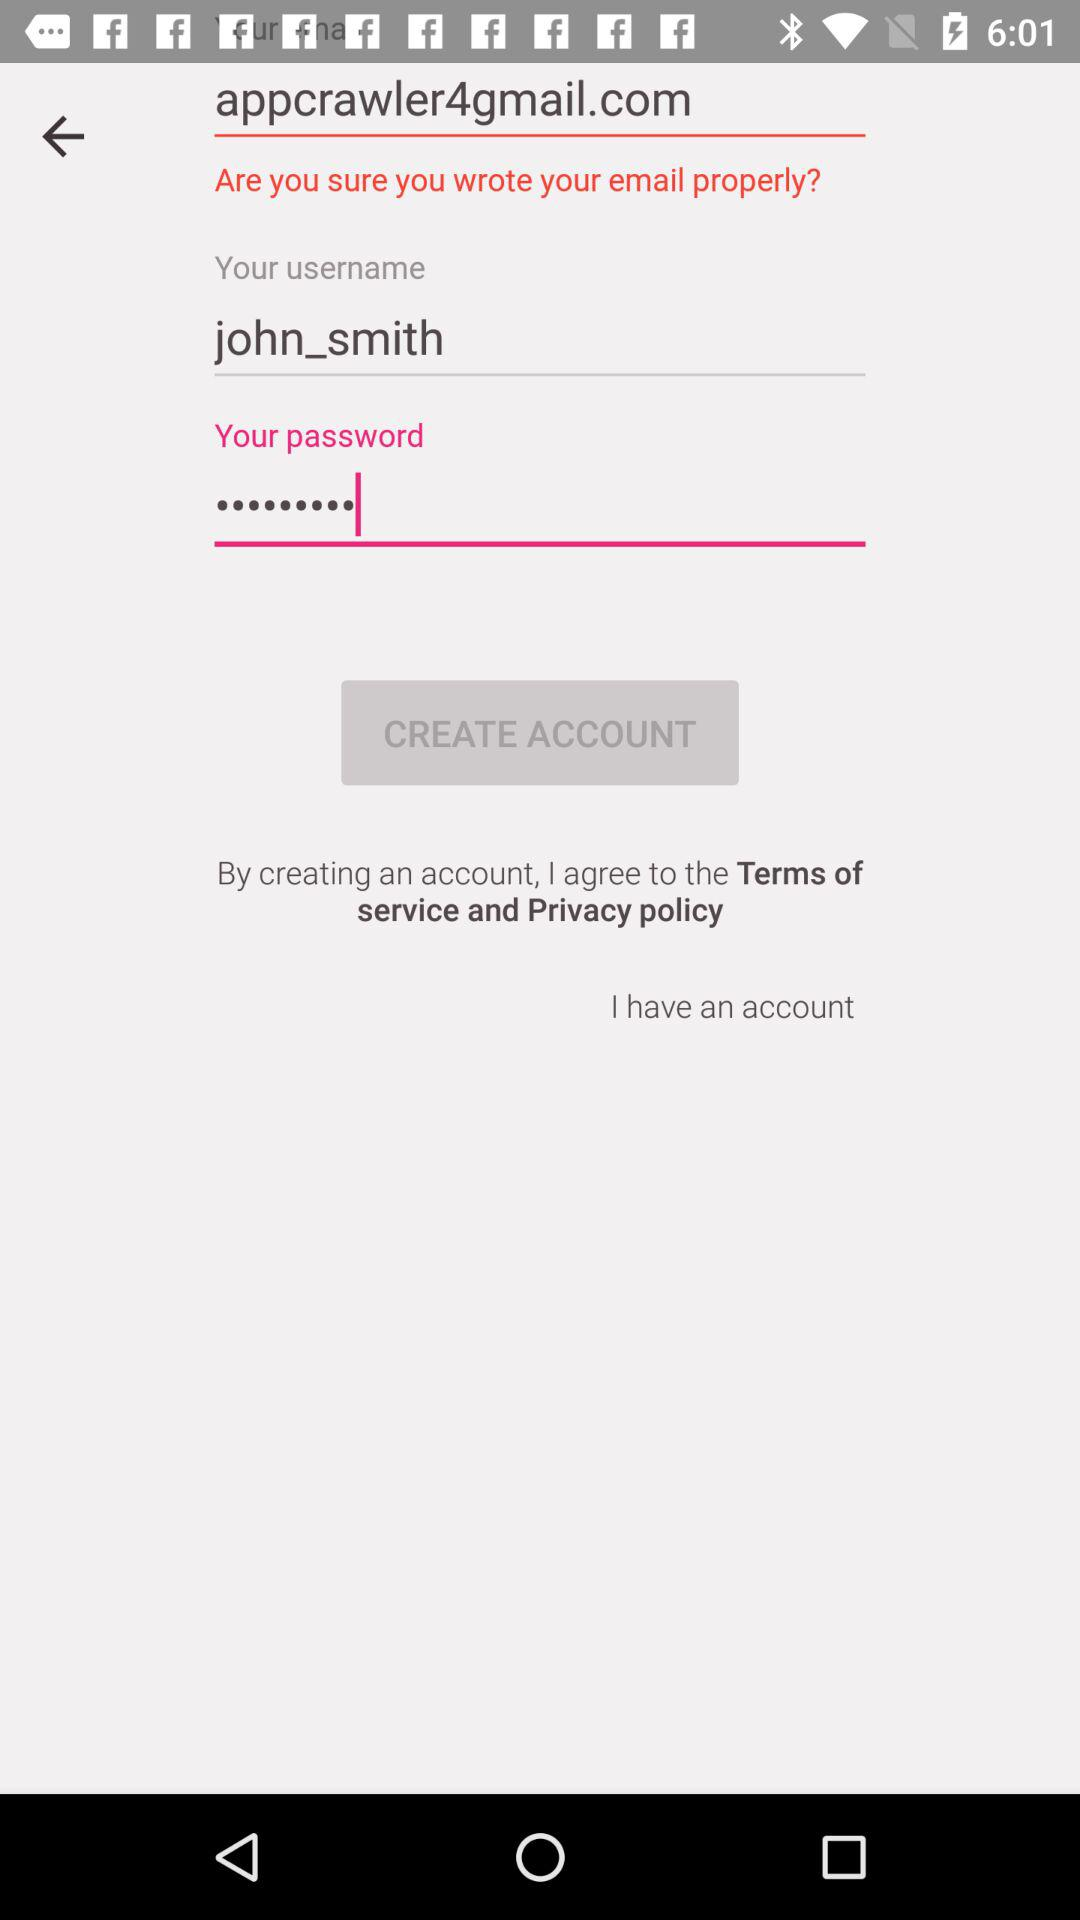What is the username? The username is "john_smith". 